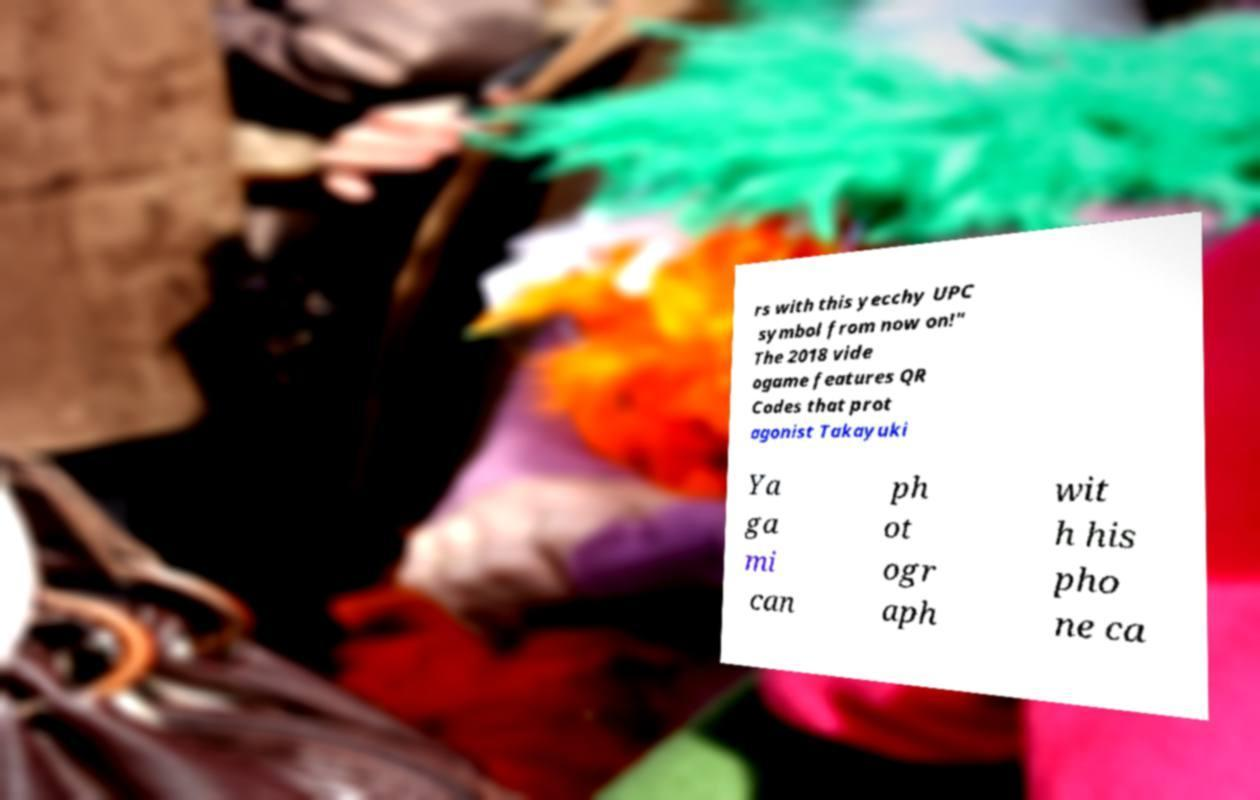I need the written content from this picture converted into text. Can you do that? rs with this yecchy UPC symbol from now on!" The 2018 vide ogame features QR Codes that prot agonist Takayuki Ya ga mi can ph ot ogr aph wit h his pho ne ca 